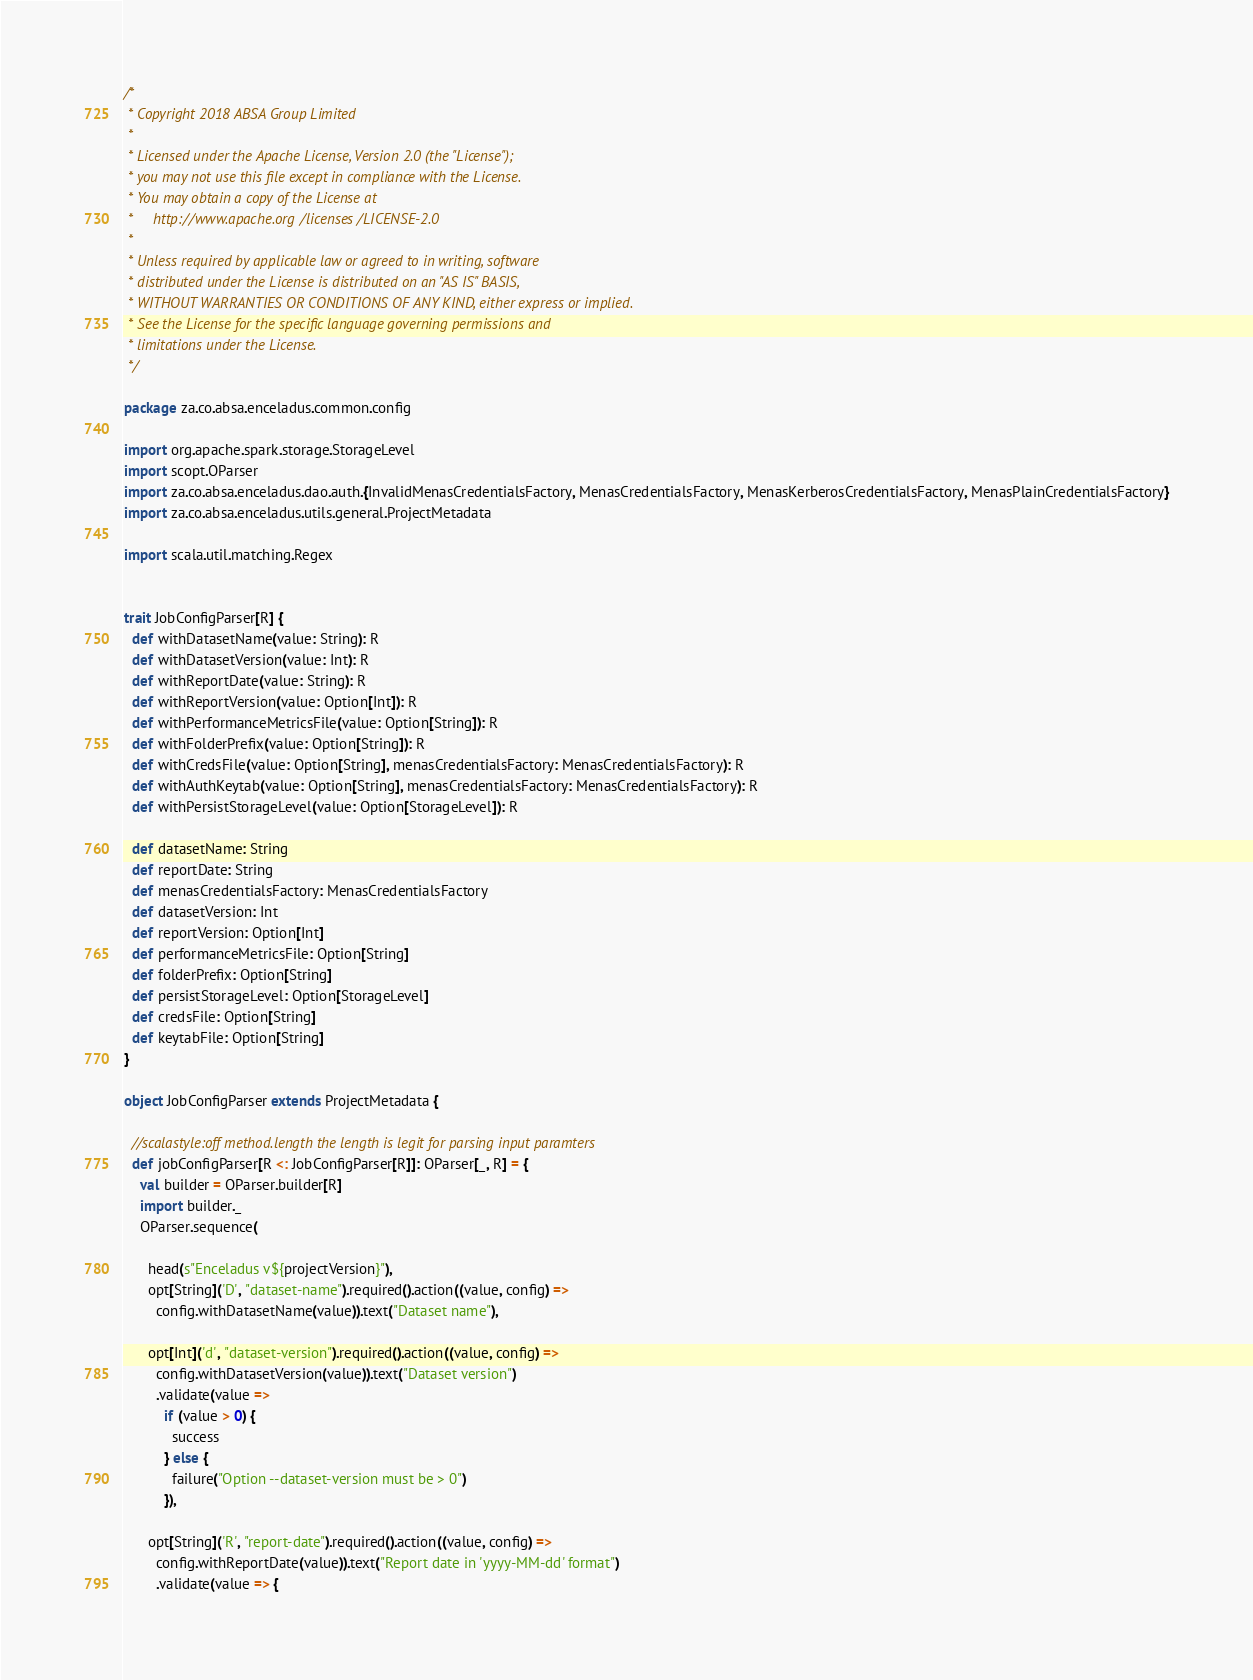<code> <loc_0><loc_0><loc_500><loc_500><_Scala_>/*
 * Copyright 2018 ABSA Group Limited
 *
 * Licensed under the Apache License, Version 2.0 (the "License");
 * you may not use this file except in compliance with the License.
 * You may obtain a copy of the License at
 *     http://www.apache.org/licenses/LICENSE-2.0
 *
 * Unless required by applicable law or agreed to in writing, software
 * distributed under the License is distributed on an "AS IS" BASIS,
 * WITHOUT WARRANTIES OR CONDITIONS OF ANY KIND, either express or implied.
 * See the License for the specific language governing permissions and
 * limitations under the License.
 */

package za.co.absa.enceladus.common.config

import org.apache.spark.storage.StorageLevel
import scopt.OParser
import za.co.absa.enceladus.dao.auth.{InvalidMenasCredentialsFactory, MenasCredentialsFactory, MenasKerberosCredentialsFactory, MenasPlainCredentialsFactory}
import za.co.absa.enceladus.utils.general.ProjectMetadata

import scala.util.matching.Regex


trait JobConfigParser[R] {
  def withDatasetName(value: String): R
  def withDatasetVersion(value: Int): R
  def withReportDate(value: String): R
  def withReportVersion(value: Option[Int]): R
  def withPerformanceMetricsFile(value: Option[String]): R
  def withFolderPrefix(value: Option[String]): R
  def withCredsFile(value: Option[String], menasCredentialsFactory: MenasCredentialsFactory): R
  def withAuthKeytab(value: Option[String], menasCredentialsFactory: MenasCredentialsFactory): R
  def withPersistStorageLevel(value: Option[StorageLevel]): R

  def datasetName: String
  def reportDate: String
  def menasCredentialsFactory: MenasCredentialsFactory
  def datasetVersion: Int
  def reportVersion: Option[Int]
  def performanceMetricsFile: Option[String]
  def folderPrefix: Option[String]
  def persistStorageLevel: Option[StorageLevel]
  def credsFile: Option[String]
  def keytabFile: Option[String]
}

object JobConfigParser extends ProjectMetadata {

  //scalastyle:off method.length the length is legit for parsing input paramters
  def jobConfigParser[R <: JobConfigParser[R]]: OParser[_, R] = {
    val builder = OParser.builder[R]
    import builder._
    OParser.sequence(

      head(s"Enceladus v${projectVersion}"),
      opt[String]('D', "dataset-name").required().action((value, config) =>
        config.withDatasetName(value)).text("Dataset name"),

      opt[Int]('d', "dataset-version").required().action((value, config) =>
        config.withDatasetVersion(value)).text("Dataset version")
        .validate(value =>
          if (value > 0) {
            success
          } else {
            failure("Option --dataset-version must be > 0")
          }),

      opt[String]('R', "report-date").required().action((value, config) =>
        config.withReportDate(value)).text("Report date in 'yyyy-MM-dd' format")
        .validate(value => {</code> 